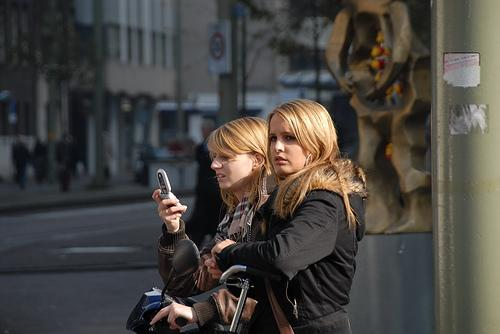The woman on the phone is using what item to move around?

Choices:
A) skateboard
B) hoverboard
C) bicycle
D) scooter scooter 